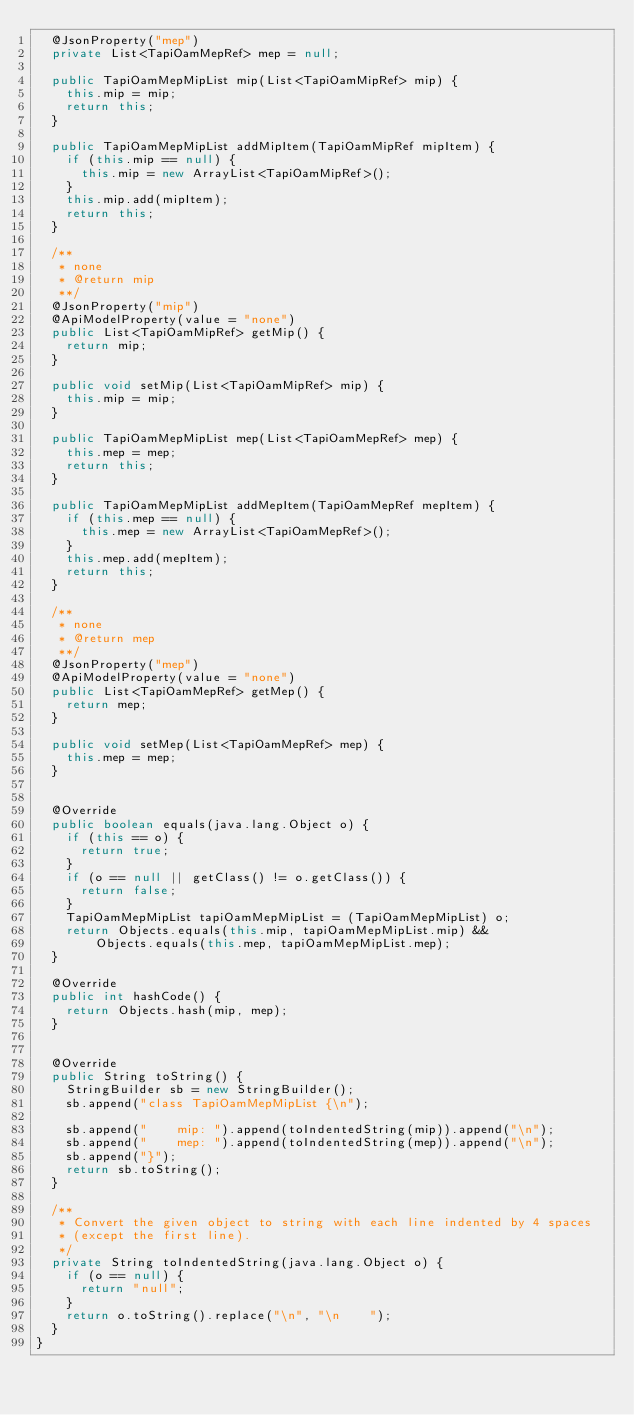Convert code to text. <code><loc_0><loc_0><loc_500><loc_500><_Java_>  @JsonProperty("mep")
  private List<TapiOamMepRef> mep = null;

  public TapiOamMepMipList mip(List<TapiOamMipRef> mip) {
    this.mip = mip;
    return this;
  }

  public TapiOamMepMipList addMipItem(TapiOamMipRef mipItem) {
    if (this.mip == null) {
      this.mip = new ArrayList<TapiOamMipRef>();
    }
    this.mip.add(mipItem);
    return this;
  }

  /**
   * none
   * @return mip
   **/
  @JsonProperty("mip")
  @ApiModelProperty(value = "none")
  public List<TapiOamMipRef> getMip() {
    return mip;
  }

  public void setMip(List<TapiOamMipRef> mip) {
    this.mip = mip;
  }

  public TapiOamMepMipList mep(List<TapiOamMepRef> mep) {
    this.mep = mep;
    return this;
  }

  public TapiOamMepMipList addMepItem(TapiOamMepRef mepItem) {
    if (this.mep == null) {
      this.mep = new ArrayList<TapiOamMepRef>();
    }
    this.mep.add(mepItem);
    return this;
  }

  /**
   * none
   * @return mep
   **/
  @JsonProperty("mep")
  @ApiModelProperty(value = "none")
  public List<TapiOamMepRef> getMep() {
    return mep;
  }

  public void setMep(List<TapiOamMepRef> mep) {
    this.mep = mep;
  }


  @Override
  public boolean equals(java.lang.Object o) {
    if (this == o) {
      return true;
    }
    if (o == null || getClass() != o.getClass()) {
      return false;
    }
    TapiOamMepMipList tapiOamMepMipList = (TapiOamMepMipList) o;
    return Objects.equals(this.mip, tapiOamMepMipList.mip) &&
        Objects.equals(this.mep, tapiOamMepMipList.mep);
  }

  @Override
  public int hashCode() {
    return Objects.hash(mip, mep);
  }


  @Override
  public String toString() {
    StringBuilder sb = new StringBuilder();
    sb.append("class TapiOamMepMipList {\n");
    
    sb.append("    mip: ").append(toIndentedString(mip)).append("\n");
    sb.append("    mep: ").append(toIndentedString(mep)).append("\n");
    sb.append("}");
    return sb.toString();
  }

  /**
   * Convert the given object to string with each line indented by 4 spaces
   * (except the first line).
   */
  private String toIndentedString(java.lang.Object o) {
    if (o == null) {
      return "null";
    }
    return o.toString().replace("\n", "\n    ");
  }
}

</code> 